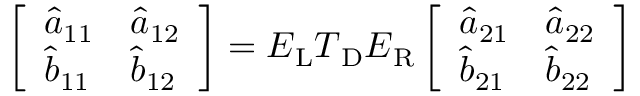<formula> <loc_0><loc_0><loc_500><loc_500>\left [ \begin{array} { l l } { \hat { a } _ { 1 1 } } & { \hat { a } _ { 1 2 } } \\ { \hat { b } _ { 1 1 } } & { \hat { b } _ { 1 2 } } \end{array} \right ] = E _ { L } T _ { D } E _ { R } \left [ \begin{array} { l l } { \hat { a } _ { 2 1 } } & { \hat { a } _ { 2 2 } } \\ { \hat { b } _ { 2 1 } } & { \hat { b } _ { 2 2 } } \end{array} \right ]</formula> 